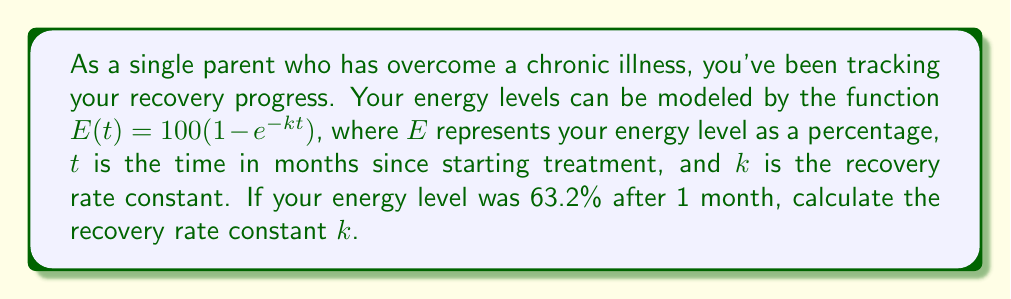Can you solve this math problem? To solve this problem, we'll follow these steps:

1) We're given the function $E(t) = 100(1 - e^{-kt})$.

2) We know that after 1 month ($t = 1$), the energy level was 63.2% ($E(1) = 63.2$).

3) Let's substitute these values into the equation:

   $63.2 = 100(1 - e^{-k(1)})$

4) Simplify:

   $0.632 = 1 - e^{-k}$

5) Subtract both sides from 1:

   $1 - 0.632 = e^{-k}$
   $0.368 = e^{-k}$

6) Take the natural logarithm of both sides:

   $\ln(0.368) = \ln(e^{-k})$
   $\ln(0.368) = -k$

7) Solve for $k$:

   $k = -\ln(0.368)$

8) Calculate the value:

   $k \approx 1$

Therefore, the recovery rate constant $k$ is approximately 1 per month.
Answer: $k \approx 1$ per month 